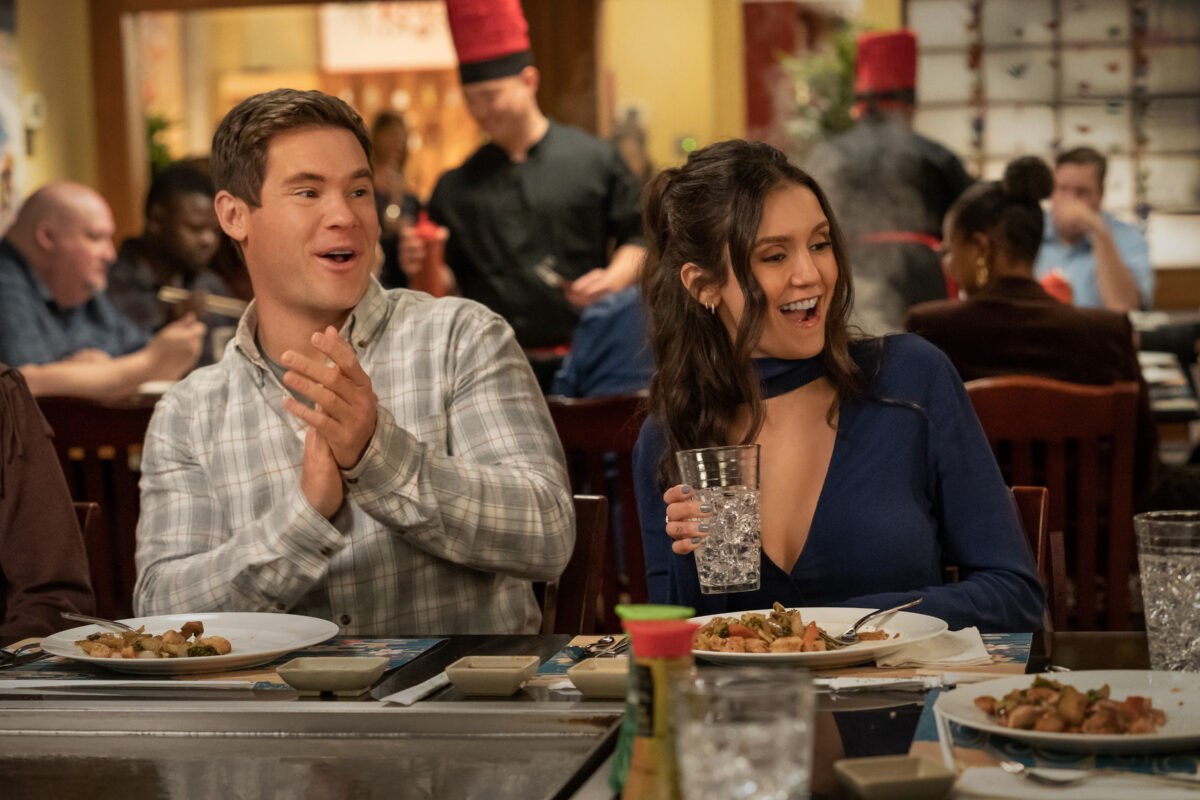They're planning something fun for the weekend. What could it be? Jessica and Alex, clearly enjoying their dinner, are excitedly discussing their plans for the upcoming weekend.

Jessica: *smiling brightly* 'So, what do you say? Should we go hiking up to Sunrise Peak on Saturday?' 
Alex: *clapping enthusiastically* 'Absolutely! I’ve been looking forward to that hike for weeks now. The view from the top is supposed to be breathtaking.'
Jessica: 'And we can pack a picnic! I’ll make those sandwiches you love.' 
Alex: 'That sounds perfect. Maybe we could even catch the sunset from the top. It’ll be an adventure!' Their faces light up with anticipation as they envision their upcoming nature escapade - a perfect blend of exercise and relaxation amidst stunning natural scenery.  Their charismatic energy is perfect for a spontaneous dance-off. Describe how it might unfold. In an infectious burst of spontaneity, Jessica and Alex decide to have an impromptu dance-off right in the middle of the restaurant. They clear a small space near their table, laughter echoing as they get into position.

Jessica: *grinning wide* 'You’re going down, Alex. Prepare to be dazzled!' 
Alex: *clapping rhythmically* 'Bring it on, Jess! Show me what you got!'
The restaurant staff and patrons, caught up in the fun, start cheering them on. Jessica kicks off with some impressive salsa moves, twirling gracefully and wowing the small audience. Alex follows with his own funky freestyle, mixing in some breakdance spins and comic flair. The two friends feed off each other’s energy, each round of the dance-off more animated and joyous than the last. The diners' applause and laughs create a wonderfully festive atmosphere, proving that sometimes, all you need for a great time is a little music and a lot of spirit. 